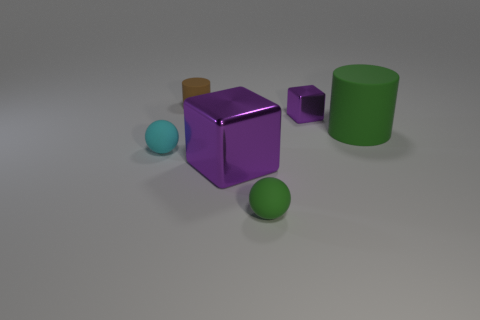What is the material of the block that is the same color as the small shiny object?
Provide a succinct answer. Metal. How many other things are the same color as the big rubber thing?
Provide a succinct answer. 1. There is a cyan matte thing; is it the same size as the ball on the right side of the small cylinder?
Give a very brief answer. Yes. There is a green ball on the left side of the block behind the tiny ball that is behind the green rubber ball; what is its size?
Your answer should be compact. Small. There is a small brown cylinder; how many cylinders are right of it?
Provide a succinct answer. 1. What is the material of the large object on the left side of the green sphere to the right of the brown matte thing?
Your response must be concise. Metal. Do the cyan rubber sphere and the brown cylinder have the same size?
Provide a short and direct response. Yes. How many objects are either cubes that are on the left side of the tiny purple object or rubber balls that are right of the tiny matte cylinder?
Your response must be concise. 2. Are there more things on the right side of the tiny green ball than big green matte objects?
Provide a succinct answer. Yes. What number of other objects are the same shape as the tiny brown thing?
Provide a succinct answer. 1. 